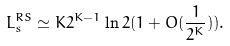<formula> <loc_0><loc_0><loc_500><loc_500>L _ { s } ^ { R S } \simeq K 2 ^ { K - 1 } \ln 2 ( 1 + O ( \frac { 1 } { 2 ^ { K } } ) ) .</formula> 